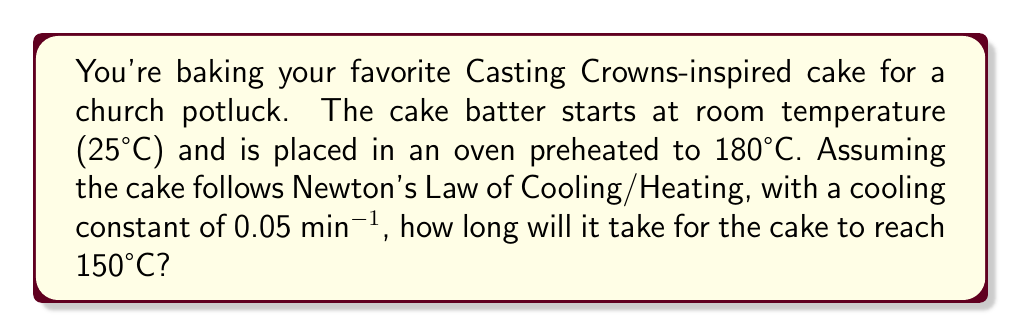Help me with this question. Let's approach this step-by-step using Newton's Law of Cooling/Heating:

1) The general form of Newton's Law is:

   $$\frac{dT}{dt} = k(T_s - T)$$

   Where:
   - $T$ is the temperature of the cake
   - $T_s$ is the surrounding temperature (oven temperature)
   - $k$ is the cooling/heating constant

2) Integrating this equation gives us:

   $$T(t) = T_s + (T_0 - T_s)e^{-kt}$$

   Where $T_0$ is the initial temperature of the cake.

3) We're given:
   - $T_0 = 25°C$ (initial cake temperature)
   - $T_s = 180°C$ (oven temperature)
   - $k = 0.05$ min^(-1) (cooling/heating constant)
   - We want to find $t$ when $T(t) = 150°C$

4) Plugging these values into our equation:

   $$150 = 180 + (25 - 180)e^{-0.05t}$$

5) Simplifying:

   $$-30 = -155e^{-0.05t}$$

6) Dividing both sides by -155:

   $$\frac{30}{155} = e^{-0.05t}$$

7) Taking the natural log of both sides:

   $$\ln(\frac{30}{155}) = -0.05t$$

8) Solving for $t$:

   $$t = -\frac{\ln(\frac{30}{155})}{0.05} \approx 33.27$$

Therefore, it will take approximately 33.27 minutes for the cake to reach 150°C.
Answer: 33.27 minutes 